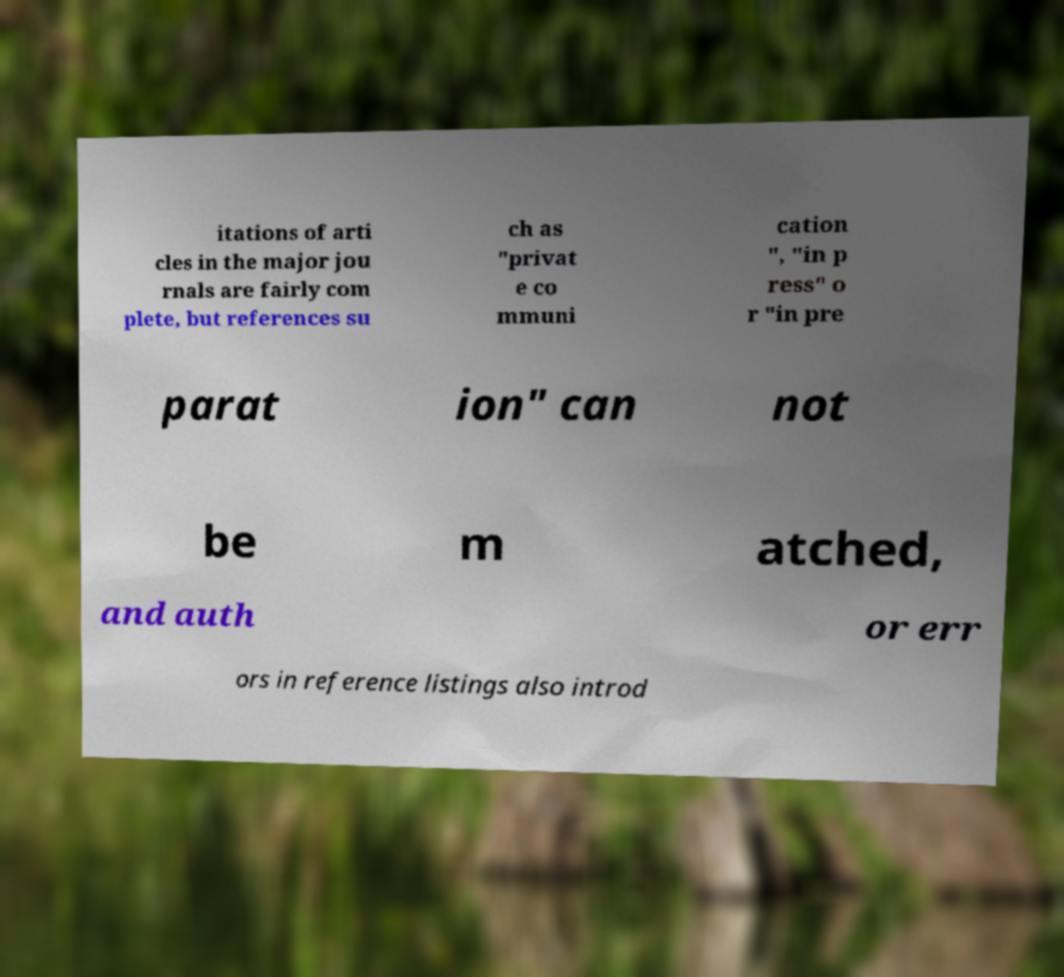Could you extract and type out the text from this image? itations of arti cles in the major jou rnals are fairly com plete, but references su ch as "privat e co mmuni cation ", "in p ress" o r "in pre parat ion" can not be m atched, and auth or err ors in reference listings also introd 